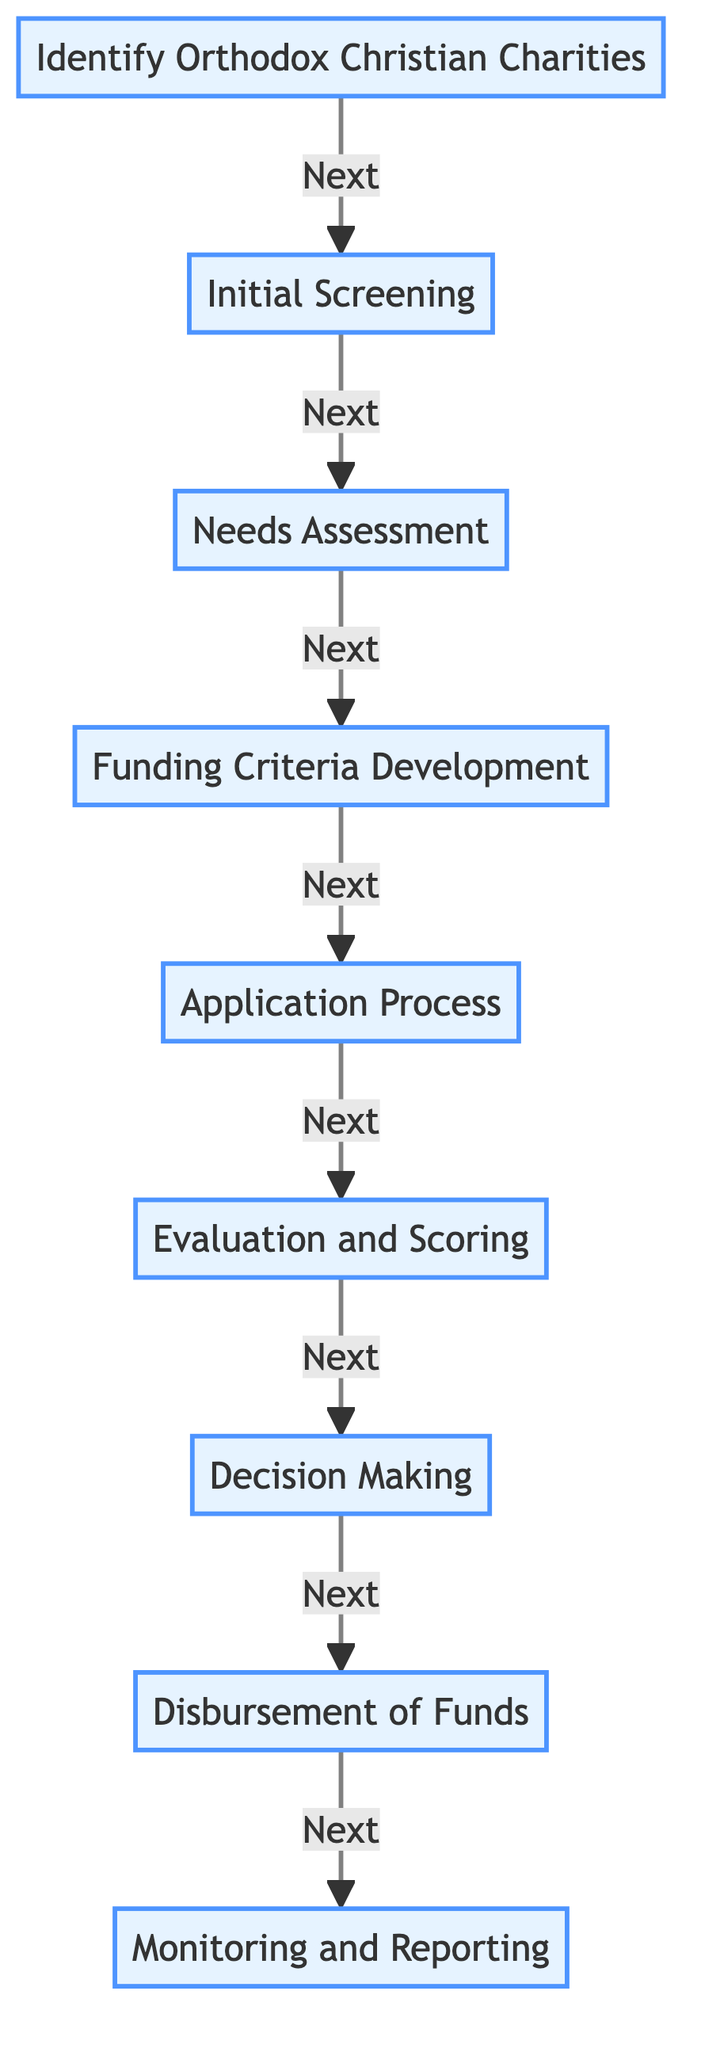What is the first step in the funding allocation process? The first step is "Identify Orthodox Christian Charities," as shown at the beginning of the flowchart.
Answer: Identify Orthodox Christian Charities How many steps are there in the funding allocation process? By counting the nodes in the flowchart, we see that there are nine distinct steps in total.
Answer: 9 What follows the "Application Process"? "Evaluation and Scoring" comes directly after the "Application Process," indicating the next action to be taken.
Answer: Evaluation and Scoring What is the last step of the process? The last step listed in the flowchart is "Monitoring and Reporting," which concludes the funding allocation procedure.
Answer: Monitoring and Reporting Which step involves checking the legitimacy of charities? The "Initial Screening" step is where the legitimacy of each charity is verified.
Answer: Initial Screening What criteria are established after the needs assessment? The "Funding Criteria Development" step follows the needs assessment, where criteria based on various factors are established.
Answer: Funding Criteria Development Which nodes are directly connected to "Decision Making"? The nodes "Evaluation and Scoring" and "Disbursement of Funds" are directly connected to "Decision Making," indicating sequential actions.
Answer: Evaluation and Scoring, Disbursement of Funds In what stage do charities submit their funding applications? Charities submit their applications in the "Application Process" stage, as indicated in the flowchart.
Answer: Application Process What ensures the effectiveness and transparency of fund usage? "Monitoring and Reporting" ensures that the funds are used effectively and transparently, as specified in the final step.
Answer: Monitoring and Reporting 